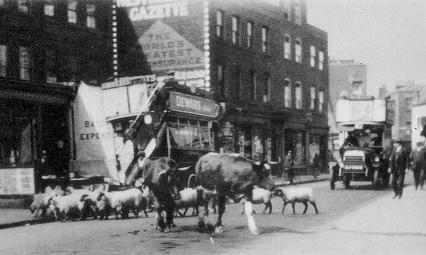Is the photo in black and white?
Be succinct. Yes. Where would you look in the picture for the local newspaper?
Concise answer only. Newsstand. Is there a local newspaper?
Answer briefly. Yes. 